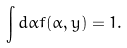Convert formula to latex. <formula><loc_0><loc_0><loc_500><loc_500>\int d \alpha f ( \alpha , y ) = 1 .</formula> 